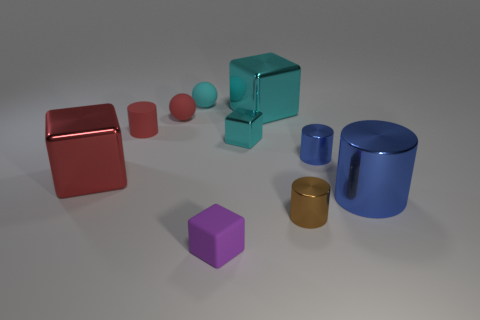How many other objects are the same material as the tiny blue object?
Your answer should be compact. 5. The small shiny cube has what color?
Provide a succinct answer. Cyan. How many purple rubber blocks are to the right of the cyan block that is behind the tiny rubber cylinder?
Provide a short and direct response. 0. Are there any tiny red objects that are behind the rubber cylinder to the right of the red metallic thing?
Your answer should be compact. Yes. There is a brown metallic cylinder; are there any tiny purple rubber blocks behind it?
Offer a very short reply. No. There is a tiny rubber object in front of the red cylinder; is its shape the same as the brown object?
Offer a very short reply. No. What number of tiny things have the same shape as the big cyan thing?
Provide a succinct answer. 2. Are there any large blue cylinders made of the same material as the small cyan cube?
Your answer should be compact. Yes. There is a cylinder in front of the big metal thing that is in front of the red cube; what is its material?
Make the answer very short. Metal. There is a blue metal object that is in front of the red cube; how big is it?
Keep it short and to the point. Large. 